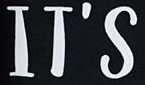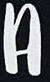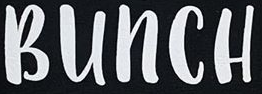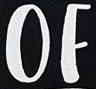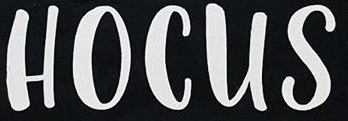What text is displayed in these images sequentially, separated by a semicolon? IT'S; A; BUNCH; OF; HOCUS 